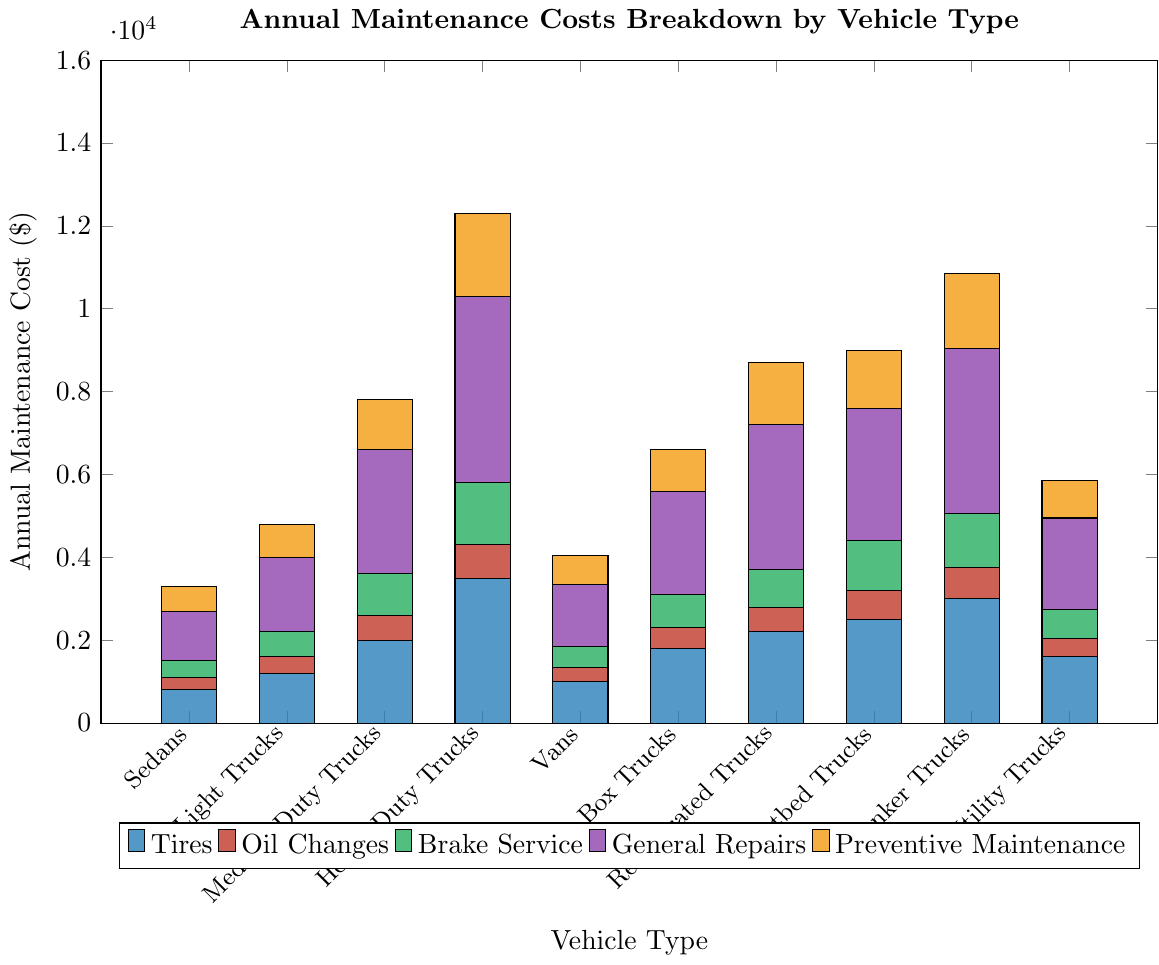what is the total annual tire maintenance cost for Light Trucks and Heavy-Duty Trucks combined? To find the total annual tire maintenance cost for Light Trucks and Heavy-Duty Trucks combined, look at the height of the Light Trucks bar representing Tires (1200) and the height of the Heavy-Duty Trucks bar representing Tires (3500). Sum these two values: 1200 + 3500 = 4700
Answer: 4700 Which vehicle type has the highest cost for General Repairs? Check the height of the General Repairs section of each bar. The tallest bar segment for General Repairs is for Heavy-Duty Trucks at 4500.
Answer: Heavy-Duty Trucks What is the difference in annual Brake Service cost between Tanker Trucks and Utility Trucks? Compare the heights of the Brake Service bars for Tanker Trucks (1300) and Utility Trucks (700). Calculate the difference: 1300 - 700 = 600
Answer: 600 Which two vehicle types have the closest annual cost for Preventive Maintenance? Compare the heights of the Preventive Maintenance bar segments. Sedans and Utility Trucks have the closest values with 600 and 700 respectively. The difference is 100.
Answer: Sedans and Utility Trucks What is the average annual cost for Oil Changes across all vehicle types? Sum the Oil Changes for all vehicle types: 300 + 400 + 600 + 800 + 350 + 500 + 600 + 700 + 750 + 450 = 5450. Divide by the number of vehicle types: 5450 / 10 = 545
Answer: 545 Rank the vehicle types from highest to lowest total annual maintenance costs. Calculate the total maintenance cost for each vehicle type by summing the costs of Tires, Oil Changes, Brake Service, General Repairs, and Preventive Maintenance: 
- Sedans: 3300 
- Light Trucks: 4800 
- Medium-Duty Trucks: 7800 
- Heavy-Duty Trucks: 12300 
- Vans: 4050 
- Box Trucks: 6600 
- Refrigerated Trucks: 8700 
- Flatbed Trucks: 9200 
- Tanker Trucks: 10850 
- Utility Trucks: 5850
Rank: Heavy-Duty Trucks > Tanker Trucks > Flatbed Trucks > Refrigerated Trucks > Medium-Duty Trucks > Box Trucks > Utility Trucks > Vans > Light Trucks > Sedans
Answer: Heavy-Duty Trucks, Tanker Trucks, Flatbed Trucks, Refrigerated Trucks, Medium-Duty Trucks, Box Trucks, Utility Trucks, Vans, Light Trucks, Sedans What is the total combined annual maintenance cost for all vehicle types? Calculate the sum of the total maintenance costs across all vehicle types:
3300 (Sedans) + 4800 (Light Trucks) + 7800 (Medium-Duty Trucks) + 12300 (Heavy-Duty Trucks) + 4050 (Vans) + 6600 (Box Trucks) + 8700 (Refrigerated Trucks) + 9200 (Flatbed Trucks) + 10850 (Tanker Trucks) + 5850 (Utility Trucks) = 72350
Answer: 72350 